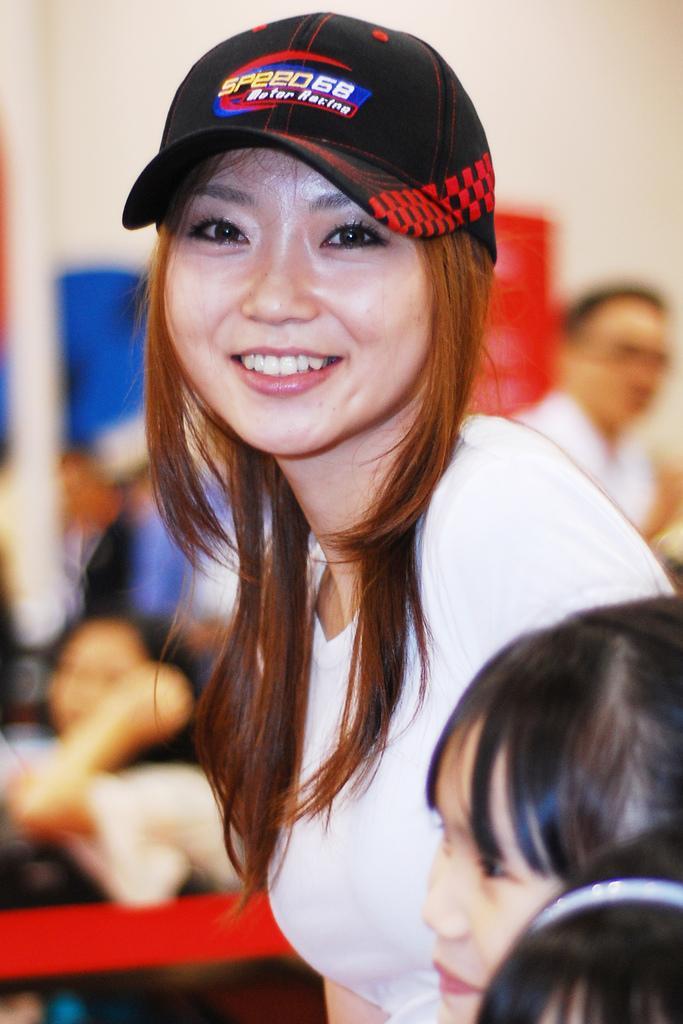Describe this image in one or two sentences. In this image I can see number of people and in the front I can see one of them is wearing a black colour cap and a white colour top. I can also see smile on her face and I can see this image is little bit blurry. 